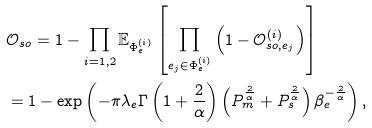<formula> <loc_0><loc_0><loc_500><loc_500>& \mathcal { O } _ { s o } = 1 - \prod _ { i = 1 , 2 } \mathbb { E } _ { \Phi ^ { ( i ) } _ { e } } \left [ \prod _ { e _ { j } \in \Phi ^ { ( i ) } _ { e } } \left ( 1 - \mathcal { O } ^ { ( i ) } _ { s o , e _ { j } } \right ) \right ] \\ & = 1 - \exp \left ( - { \pi \lambda _ { e } } \Gamma \left ( 1 + \frac { 2 } { \alpha } \right ) \left ( { P _ { m } ^ { \frac { 2 } { \alpha } } } + { P _ { s } ^ { \frac { 2 } { \alpha } } } \right ) \beta _ { e } ^ { - \frac { 2 } { \alpha } } \right ) ,</formula> 